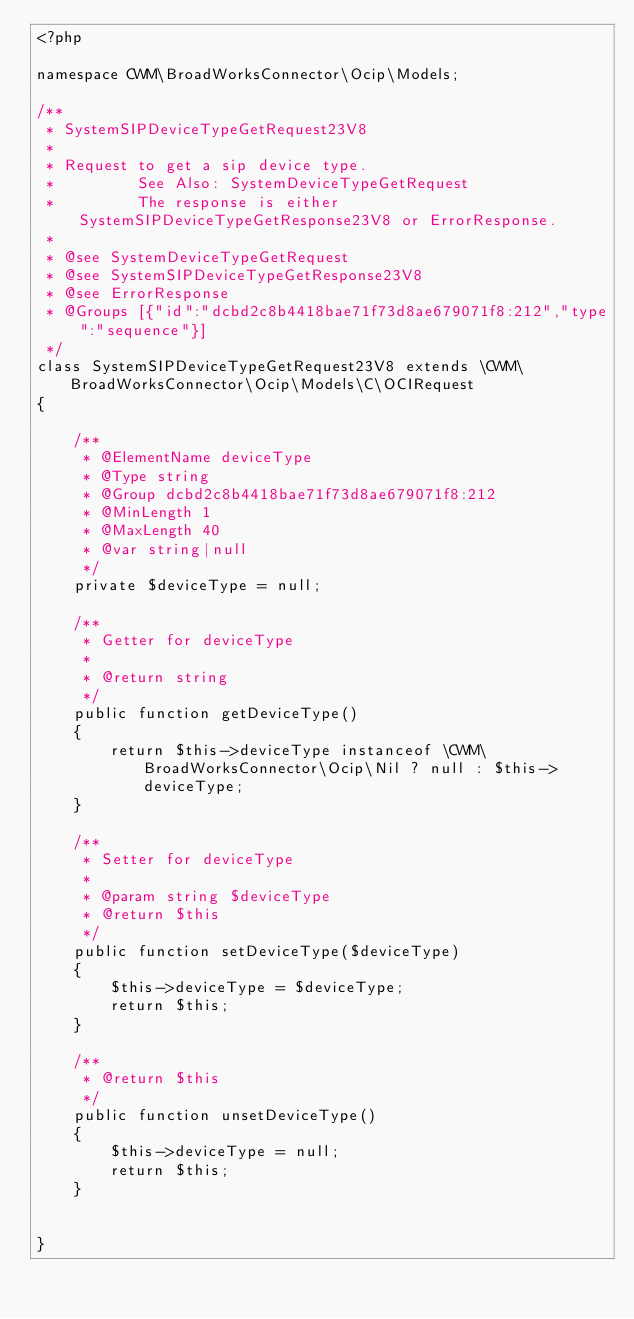<code> <loc_0><loc_0><loc_500><loc_500><_PHP_><?php

namespace CWM\BroadWorksConnector\Ocip\Models;

/**
 * SystemSIPDeviceTypeGetRequest23V8
 *
 * Request to get a sip device type.
 *         See Also: SystemDeviceTypeGetRequest
 *         The response is either SystemSIPDeviceTypeGetResponse23V8 or ErrorResponse.
 *
 * @see SystemDeviceTypeGetRequest
 * @see SystemSIPDeviceTypeGetResponse23V8
 * @see ErrorResponse
 * @Groups [{"id":"dcbd2c8b4418bae71f73d8ae679071f8:212","type":"sequence"}]
 */
class SystemSIPDeviceTypeGetRequest23V8 extends \CWM\BroadWorksConnector\Ocip\Models\C\OCIRequest
{

    /**
     * @ElementName deviceType
     * @Type string
     * @Group dcbd2c8b4418bae71f73d8ae679071f8:212
     * @MinLength 1
     * @MaxLength 40
     * @var string|null
     */
    private $deviceType = null;

    /**
     * Getter for deviceType
     *
     * @return string
     */
    public function getDeviceType()
    {
        return $this->deviceType instanceof \CWM\BroadWorksConnector\Ocip\Nil ? null : $this->deviceType;
    }

    /**
     * Setter for deviceType
     *
     * @param string $deviceType
     * @return $this
     */
    public function setDeviceType($deviceType)
    {
        $this->deviceType = $deviceType;
        return $this;
    }

    /**
     * @return $this
     */
    public function unsetDeviceType()
    {
        $this->deviceType = null;
        return $this;
    }


}

</code> 